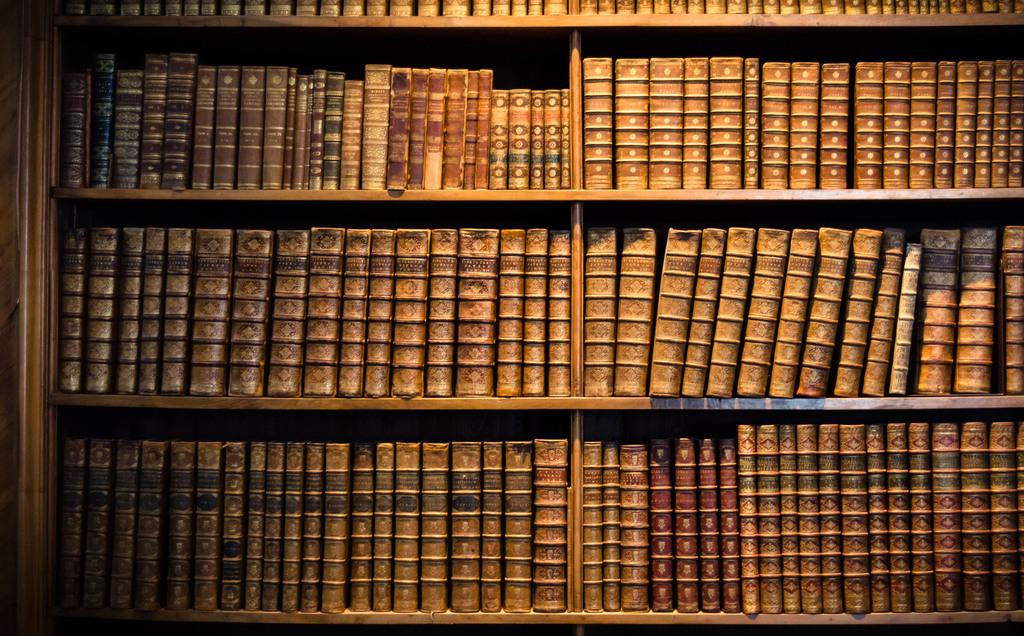What can be seen in the image that is arranged in a rack? There are objects arranged in a rack in the image. What type of attack is being carried out by the objects in the image? There is no attack or any indication of an attack in the image; it simply shows objects arranged in a rack. 